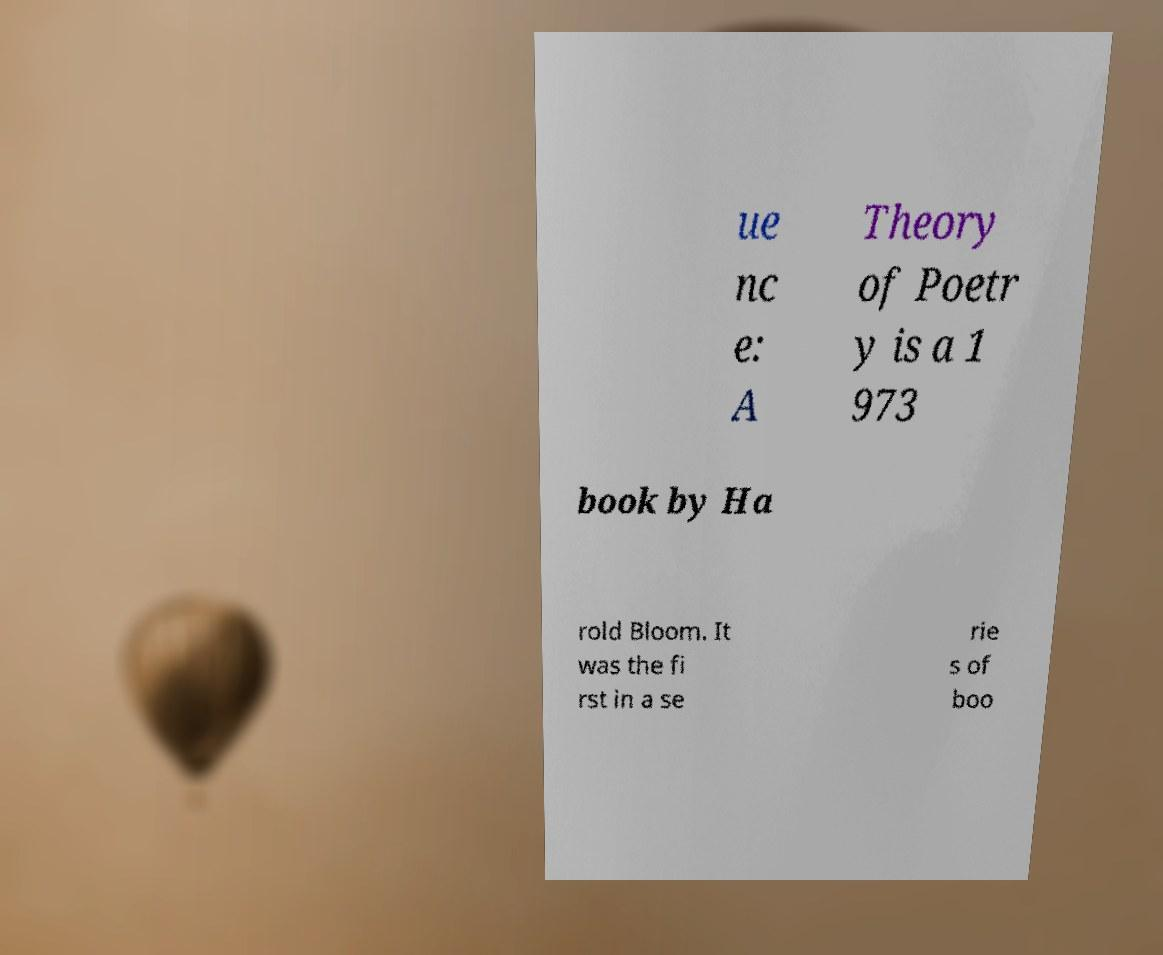Could you extract and type out the text from this image? ue nc e: A Theory of Poetr y is a 1 973 book by Ha rold Bloom. It was the fi rst in a se rie s of boo 